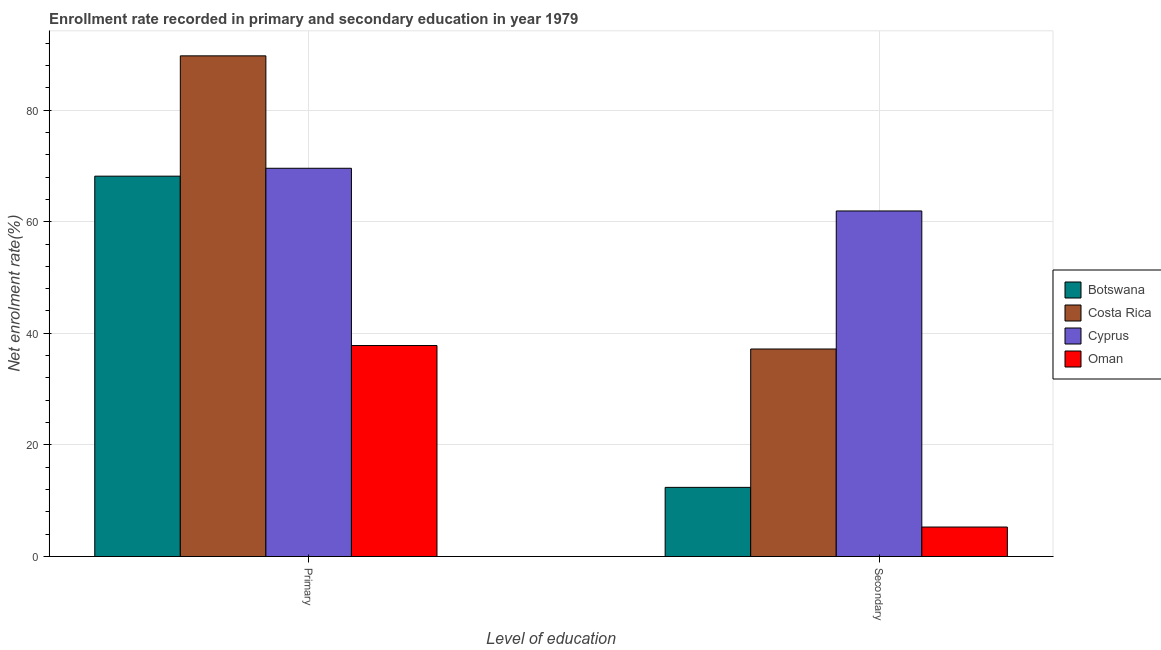How many groups of bars are there?
Your answer should be compact. 2. Are the number of bars on each tick of the X-axis equal?
Keep it short and to the point. Yes. How many bars are there on the 1st tick from the left?
Your answer should be compact. 4. How many bars are there on the 1st tick from the right?
Your response must be concise. 4. What is the label of the 1st group of bars from the left?
Offer a terse response. Primary. What is the enrollment rate in secondary education in Cyprus?
Give a very brief answer. 61.92. Across all countries, what is the maximum enrollment rate in primary education?
Give a very brief answer. 89.72. Across all countries, what is the minimum enrollment rate in secondary education?
Keep it short and to the point. 5.28. In which country was the enrollment rate in primary education maximum?
Provide a succinct answer. Costa Rica. In which country was the enrollment rate in secondary education minimum?
Offer a very short reply. Oman. What is the total enrollment rate in secondary education in the graph?
Offer a very short reply. 116.78. What is the difference between the enrollment rate in primary education in Cyprus and that in Oman?
Give a very brief answer. 31.77. What is the difference between the enrollment rate in secondary education in Costa Rica and the enrollment rate in primary education in Botswana?
Your response must be concise. -30.97. What is the average enrollment rate in secondary education per country?
Give a very brief answer. 29.2. What is the difference between the enrollment rate in secondary education and enrollment rate in primary education in Costa Rica?
Your answer should be compact. -52.53. In how many countries, is the enrollment rate in secondary education greater than 28 %?
Ensure brevity in your answer.  2. What is the ratio of the enrollment rate in secondary education in Botswana to that in Oman?
Provide a succinct answer. 2.35. What does the 1st bar from the left in Secondary represents?
Offer a very short reply. Botswana. What does the 2nd bar from the right in Secondary represents?
Provide a short and direct response. Cyprus. How many bars are there?
Provide a succinct answer. 8. Are the values on the major ticks of Y-axis written in scientific E-notation?
Ensure brevity in your answer.  No. Where does the legend appear in the graph?
Give a very brief answer. Center right. How many legend labels are there?
Your answer should be compact. 4. How are the legend labels stacked?
Keep it short and to the point. Vertical. What is the title of the graph?
Your response must be concise. Enrollment rate recorded in primary and secondary education in year 1979. Does "Gambia, The" appear as one of the legend labels in the graph?
Offer a terse response. No. What is the label or title of the X-axis?
Provide a succinct answer. Level of education. What is the label or title of the Y-axis?
Your answer should be very brief. Net enrolment rate(%). What is the Net enrolment rate(%) of Botswana in Primary?
Make the answer very short. 68.16. What is the Net enrolment rate(%) in Costa Rica in Primary?
Offer a very short reply. 89.72. What is the Net enrolment rate(%) of Cyprus in Primary?
Offer a terse response. 69.57. What is the Net enrolment rate(%) in Oman in Primary?
Your response must be concise. 37.81. What is the Net enrolment rate(%) in Botswana in Secondary?
Offer a very short reply. 12.39. What is the Net enrolment rate(%) of Costa Rica in Secondary?
Your answer should be very brief. 37.19. What is the Net enrolment rate(%) in Cyprus in Secondary?
Make the answer very short. 61.92. What is the Net enrolment rate(%) in Oman in Secondary?
Offer a very short reply. 5.28. Across all Level of education, what is the maximum Net enrolment rate(%) of Botswana?
Your answer should be compact. 68.16. Across all Level of education, what is the maximum Net enrolment rate(%) in Costa Rica?
Ensure brevity in your answer.  89.72. Across all Level of education, what is the maximum Net enrolment rate(%) in Cyprus?
Provide a succinct answer. 69.57. Across all Level of education, what is the maximum Net enrolment rate(%) of Oman?
Ensure brevity in your answer.  37.81. Across all Level of education, what is the minimum Net enrolment rate(%) in Botswana?
Provide a short and direct response. 12.39. Across all Level of education, what is the minimum Net enrolment rate(%) of Costa Rica?
Offer a terse response. 37.19. Across all Level of education, what is the minimum Net enrolment rate(%) in Cyprus?
Offer a very short reply. 61.92. Across all Level of education, what is the minimum Net enrolment rate(%) in Oman?
Give a very brief answer. 5.28. What is the total Net enrolment rate(%) of Botswana in the graph?
Offer a terse response. 80.55. What is the total Net enrolment rate(%) of Costa Rica in the graph?
Your answer should be compact. 126.91. What is the total Net enrolment rate(%) of Cyprus in the graph?
Offer a very short reply. 131.5. What is the total Net enrolment rate(%) of Oman in the graph?
Your answer should be compact. 43.09. What is the difference between the Net enrolment rate(%) in Botswana in Primary and that in Secondary?
Your response must be concise. 55.77. What is the difference between the Net enrolment rate(%) of Costa Rica in Primary and that in Secondary?
Your answer should be compact. 52.53. What is the difference between the Net enrolment rate(%) of Cyprus in Primary and that in Secondary?
Make the answer very short. 7.65. What is the difference between the Net enrolment rate(%) in Oman in Primary and that in Secondary?
Your answer should be compact. 32.53. What is the difference between the Net enrolment rate(%) of Botswana in Primary and the Net enrolment rate(%) of Costa Rica in Secondary?
Provide a short and direct response. 30.97. What is the difference between the Net enrolment rate(%) of Botswana in Primary and the Net enrolment rate(%) of Cyprus in Secondary?
Your response must be concise. 6.24. What is the difference between the Net enrolment rate(%) of Botswana in Primary and the Net enrolment rate(%) of Oman in Secondary?
Your response must be concise. 62.88. What is the difference between the Net enrolment rate(%) of Costa Rica in Primary and the Net enrolment rate(%) of Cyprus in Secondary?
Your response must be concise. 27.8. What is the difference between the Net enrolment rate(%) in Costa Rica in Primary and the Net enrolment rate(%) in Oman in Secondary?
Your answer should be compact. 84.44. What is the difference between the Net enrolment rate(%) of Cyprus in Primary and the Net enrolment rate(%) of Oman in Secondary?
Provide a succinct answer. 64.29. What is the average Net enrolment rate(%) of Botswana per Level of education?
Make the answer very short. 40.28. What is the average Net enrolment rate(%) of Costa Rica per Level of education?
Your answer should be very brief. 63.45. What is the average Net enrolment rate(%) in Cyprus per Level of education?
Provide a short and direct response. 65.75. What is the average Net enrolment rate(%) in Oman per Level of education?
Ensure brevity in your answer.  21.55. What is the difference between the Net enrolment rate(%) of Botswana and Net enrolment rate(%) of Costa Rica in Primary?
Give a very brief answer. -21.56. What is the difference between the Net enrolment rate(%) in Botswana and Net enrolment rate(%) in Cyprus in Primary?
Your response must be concise. -1.41. What is the difference between the Net enrolment rate(%) of Botswana and Net enrolment rate(%) of Oman in Primary?
Keep it short and to the point. 30.35. What is the difference between the Net enrolment rate(%) in Costa Rica and Net enrolment rate(%) in Cyprus in Primary?
Give a very brief answer. 20.15. What is the difference between the Net enrolment rate(%) in Costa Rica and Net enrolment rate(%) in Oman in Primary?
Your answer should be compact. 51.91. What is the difference between the Net enrolment rate(%) in Cyprus and Net enrolment rate(%) in Oman in Primary?
Your answer should be very brief. 31.77. What is the difference between the Net enrolment rate(%) in Botswana and Net enrolment rate(%) in Costa Rica in Secondary?
Your answer should be compact. -24.8. What is the difference between the Net enrolment rate(%) in Botswana and Net enrolment rate(%) in Cyprus in Secondary?
Your response must be concise. -49.53. What is the difference between the Net enrolment rate(%) in Botswana and Net enrolment rate(%) in Oman in Secondary?
Offer a very short reply. 7.11. What is the difference between the Net enrolment rate(%) of Costa Rica and Net enrolment rate(%) of Cyprus in Secondary?
Give a very brief answer. -24.74. What is the difference between the Net enrolment rate(%) of Costa Rica and Net enrolment rate(%) of Oman in Secondary?
Your answer should be compact. 31.9. What is the difference between the Net enrolment rate(%) of Cyprus and Net enrolment rate(%) of Oman in Secondary?
Provide a succinct answer. 56.64. What is the ratio of the Net enrolment rate(%) of Botswana in Primary to that in Secondary?
Keep it short and to the point. 5.5. What is the ratio of the Net enrolment rate(%) in Costa Rica in Primary to that in Secondary?
Ensure brevity in your answer.  2.41. What is the ratio of the Net enrolment rate(%) in Cyprus in Primary to that in Secondary?
Give a very brief answer. 1.12. What is the ratio of the Net enrolment rate(%) in Oman in Primary to that in Secondary?
Make the answer very short. 7.16. What is the difference between the highest and the second highest Net enrolment rate(%) of Botswana?
Your answer should be very brief. 55.77. What is the difference between the highest and the second highest Net enrolment rate(%) in Costa Rica?
Keep it short and to the point. 52.53. What is the difference between the highest and the second highest Net enrolment rate(%) in Cyprus?
Give a very brief answer. 7.65. What is the difference between the highest and the second highest Net enrolment rate(%) of Oman?
Your response must be concise. 32.53. What is the difference between the highest and the lowest Net enrolment rate(%) in Botswana?
Your answer should be very brief. 55.77. What is the difference between the highest and the lowest Net enrolment rate(%) in Costa Rica?
Give a very brief answer. 52.53. What is the difference between the highest and the lowest Net enrolment rate(%) of Cyprus?
Offer a very short reply. 7.65. What is the difference between the highest and the lowest Net enrolment rate(%) of Oman?
Give a very brief answer. 32.53. 